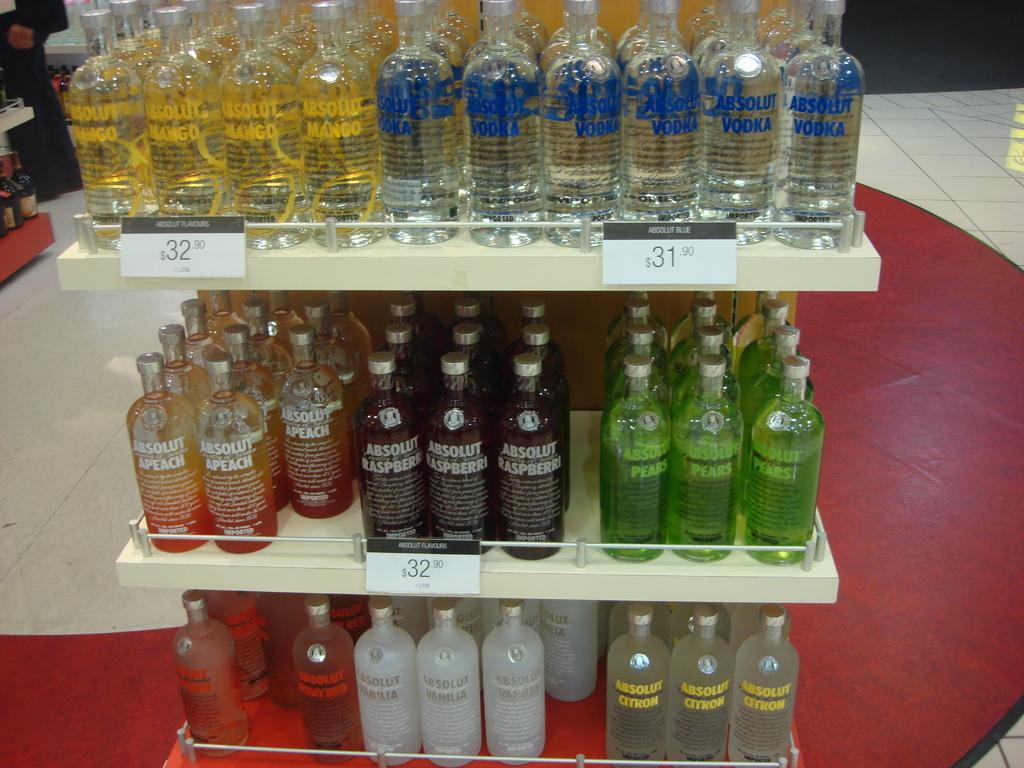<image>
Render a clear and concise summary of the photo. Absolute vodka on a special offer in a store. 